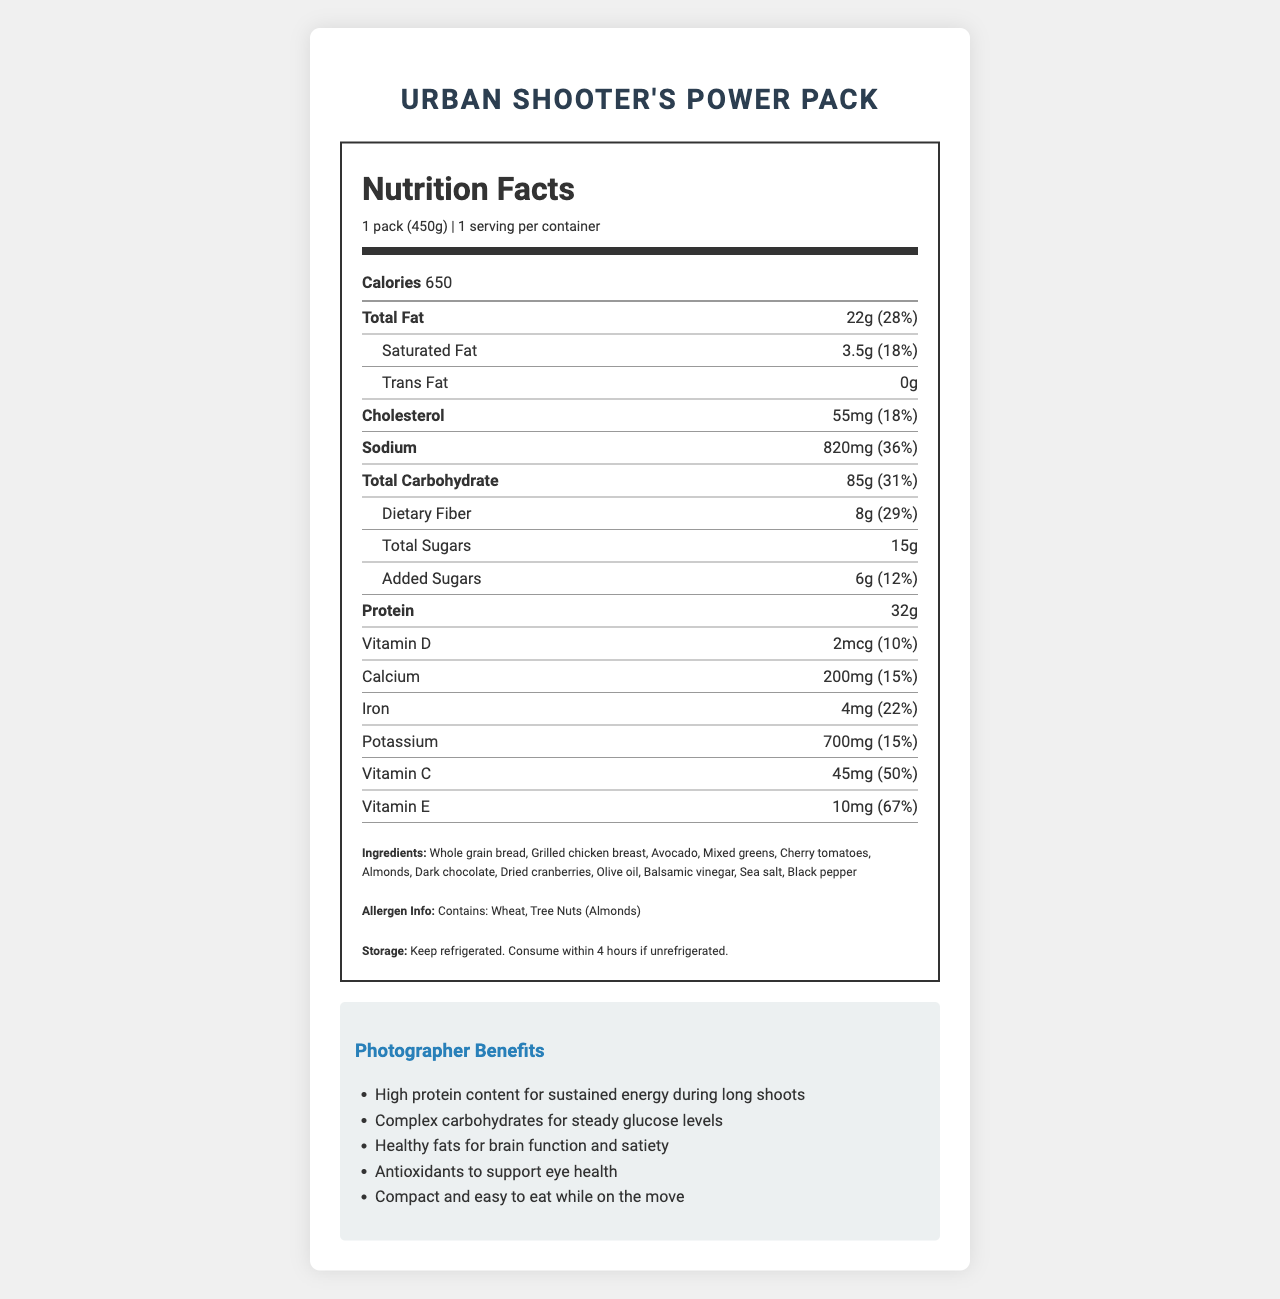How many servings are there in one container of the Urban Shooter's Power Pack? The serving information in the nutrition label states that there is 1 serving per container.
Answer: 1 What is the total calorie content in the Urban Shooter's Power Pack? The calorie content is clearly listed under the calories section in the nutrition label.
Answer: 650 What is the serving size of the Urban Shooter's Power Pack? The serving size is specified as "1 pack (450g)" in the document.
Answer: 1 pack (450g) How much protein is in a serving of the Urban Shooter's Power Pack? According to the nutrition label, a serving contains 32 grams of protein.
Answer: 32g What is the percentage of Daily Value for total fat in the Urban Shooter's Power Pack? The nutrition label lists the total fat as 22g, which is 28% of the daily value.
Answer: 28% Which allergen does the Urban Shooter’s Power Pack contain? A. Dairy B. Gluten C. Tree Nuts D. Soy The allergen information specifies that the product contains Tree Nuts (Almonds).
Answer: C What is the percentage of Daily Value for sodium in the Urban Shooter's Power Pack? The nutrition label shows that the sodium content is 820mg, which is 36% of the daily value.
Answer: 36% Does the Urban Shooter's Power Pack contain any trans fat? (True/False) The nutrition label indicates that the trans fat content is 0g.
Answer: False What are the compact and easy-to-eat benefits of the Urban Shooter's Power Pack? The document lists "Compact and easy to eat while on the move" under the photographer benefits section.
Answer: Compact and easy to eat while on the move How much Vitamin C does the Urban Shooter's Power Pack provide per serving? The nutrition label indicates that each serving provides 45mg of Vitamin C.
Answer: 45mg How much dietary fiber does a serving of the Urban Shooter's Power Pack contain? The nutrition facts label states that the dietary fiber content is 8 grams per serving.
Answer: 8g How is the Urban Shooter's Power Pack intended to be stored? The storage instructions specify to keep the pack refrigerated or consume it within 4 hours if unrefrigerated.
Answer: Keep refrigerated. Consume within 4 hours if unrefrigerated. Which of the following is NOT listed as a photographer benefit in the document? A. High protein content for sustained energy B. Compact and easy to store C. Antioxidants to support eye health D. Healthy fats for brain function and satiety "Compact and easy to store" is not mentioned; the document instead lists "Compact and easy to eat while on the move."
Answer: B What is not mentioned in the photographer benefits section? There could be multiple potential benefits not mentioned, and without more context, it is not possible to determine all the benefits that might have been included.
Answer: Cannot be determined Provide a summary of the Urban Shooter's Power Pack document. The document includes detailed nutrition information, ingredients, allergen warnings, storage guidelines, and benefits specifically aimed at photographers to support long, demanding shoots.
Answer: The Urban Shooter's Power Pack document provides detailed nutrition facts of a 450g serving, which includes high protein and various nutrients beneficial for photographers. It lists the ingredients, allergen information, storage instructions, and specific benefits for photographers such as high protein content, healthy fats, and antioxidants. 